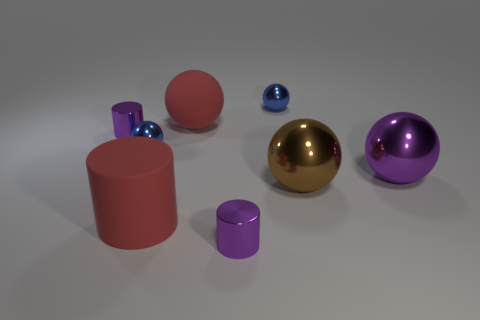How many blue spheres must be subtracted to get 1 blue spheres? 1 Subtract all brown balls. How many balls are left? 4 Subtract all big red matte balls. How many balls are left? 4 Subtract all green spheres. Subtract all cyan cylinders. How many spheres are left? 5 Add 1 large metal objects. How many objects exist? 9 Subtract all cylinders. How many objects are left? 5 Add 8 small purple cylinders. How many small purple cylinders exist? 10 Subtract 1 red balls. How many objects are left? 7 Subtract all big metallic things. Subtract all brown balls. How many objects are left? 5 Add 3 red rubber spheres. How many red rubber spheres are left? 4 